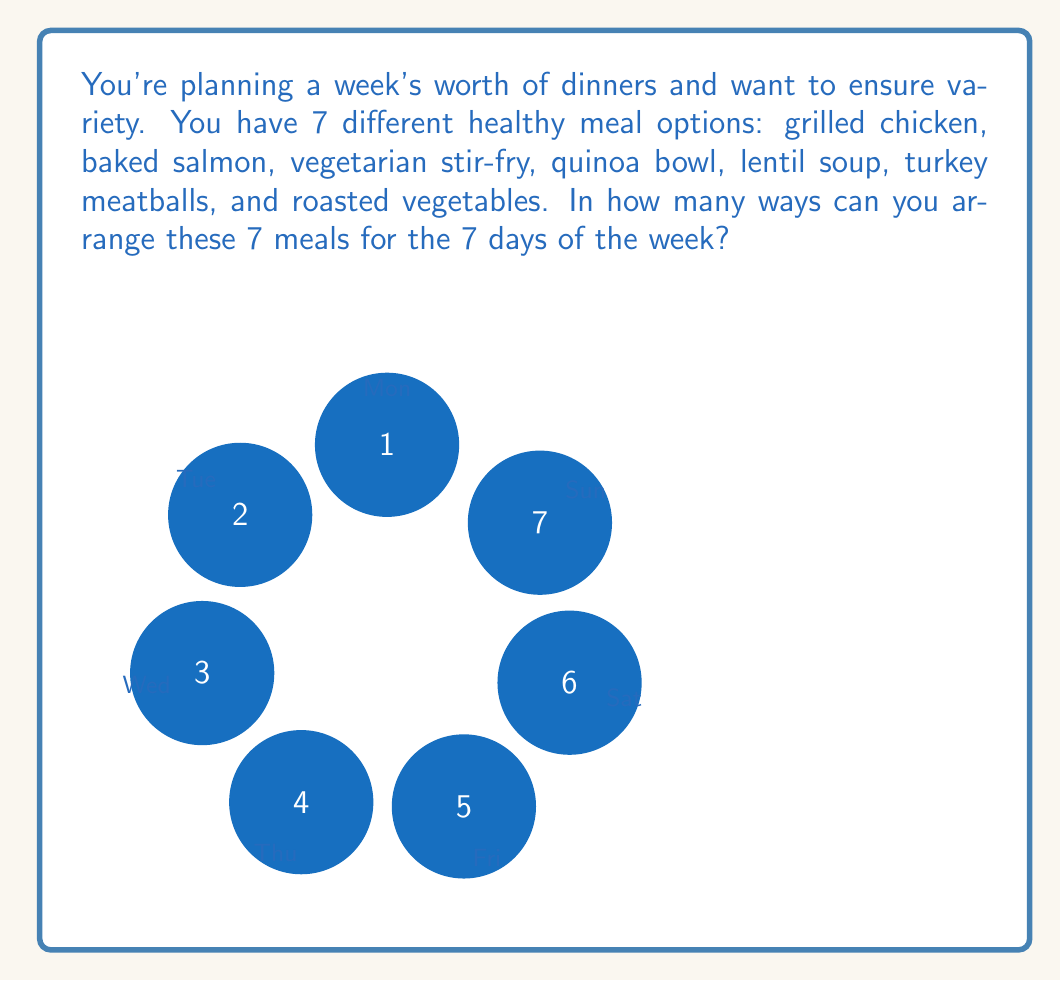Help me with this question. To solve this problem, we need to use the concept of permutations. A permutation is an arrangement of objects where order matters and all objects are used.

In this case:
1. We have 7 different meals to arrange.
2. All 7 meals must be used (one for each day of the week).
3. The order matters (the meal for Monday is different from the meal for Tuesday, etc.).

The formula for permutations of n distinct objects is:

$$P(n) = n!$$

Where $n!$ (n factorial) is the product of all positive integers less than or equal to n.

In our case, $n = 7$, so we calculate:

$$\begin{aligned}
P(7) &= 7! \\
&= 7 \times 6 \times 5 \times 4 \times 3 \times 2 \times 1 \\
&= 5040
\end{aligned}$$

Therefore, there are 5040 different ways to arrange 7 meals for the 7 days of the week.

This large number demonstrates the variety of meal plans possible, even with just 7 options, which can help maintain interest in a healthy eating routine.
Answer: 5040 